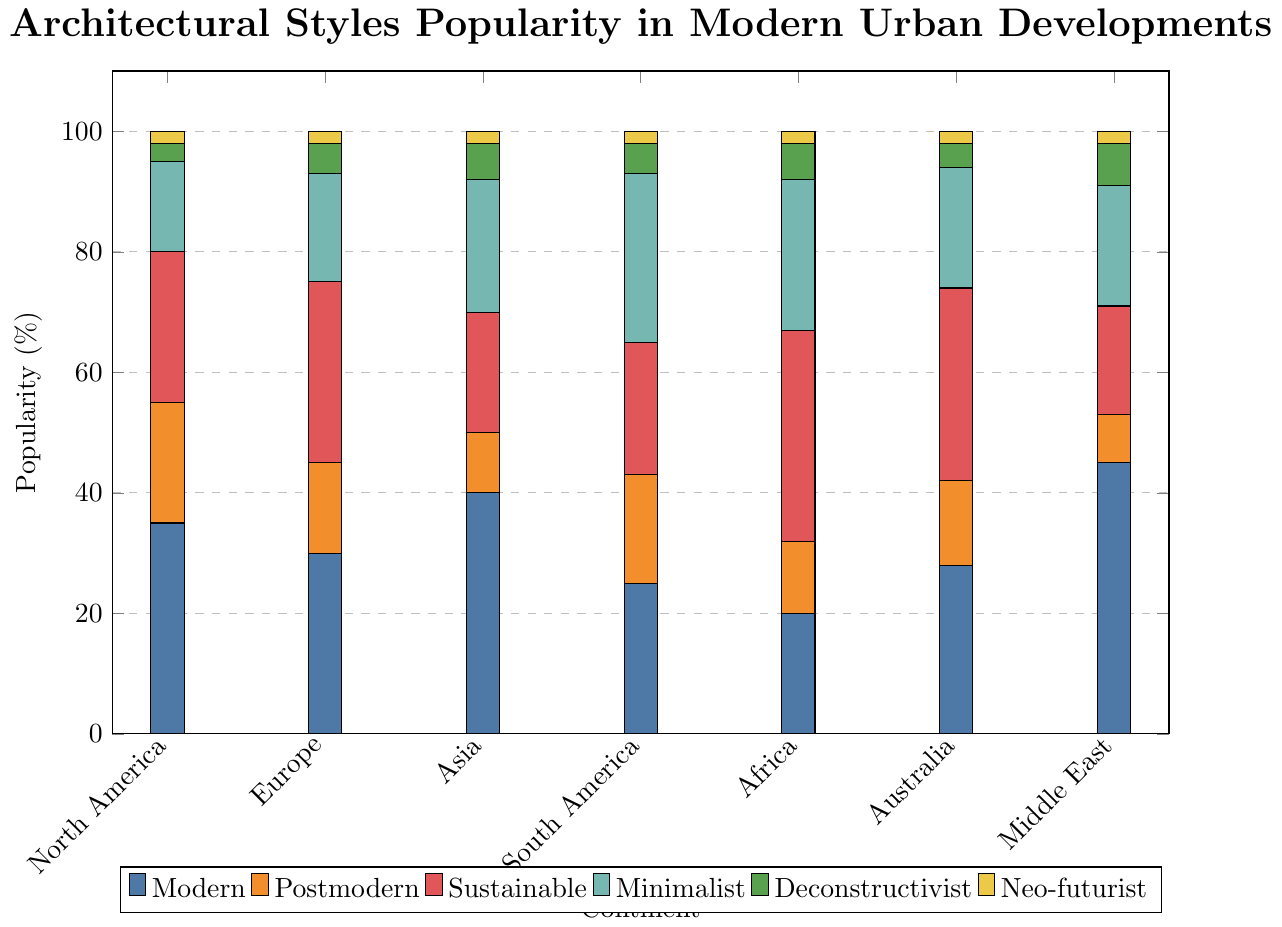Which continent has the highest popularity for Modern architecture? To find the highest popularity for Modern architecture, locate the tallest bar in the "Modern" category across all continents. The bar over the Middle East is the highest.
Answer: Middle East What is the total popularity percentage for Postmodern and Sustainable architecture in Europe? Look at the values for Postmodern (15) and Sustainable (30) architecture in Europe, then sum them up: 15 + 30 = 45
Answer: 45 Which continent exhibits the least popularity for Neo-futurist architecture? Identify the smallest bar segment representing Neo-futurist architecture across all continents. All continents have a Neo-futurist popularity of 2%.
Answer: All continents (each has 2%) Is Minimalist architecture more popular in Asia or Australia? Compare the bar heights for Minimalist architecture in Asia (22) and Australia (20). Asia has a higher value.
Answer: Asia By how much does Sustainable architecture in Africa exceed that in North America? Calculate the difference between Sustainable architecture values in Africa (35) and North America (25): 35 - 25 = 10
Answer: 10 What is the average popularity of Deconstructivist architecture across all continents? First, sum the Deconstructivist percentages across all continents: 3 + 5 + 6 + 5 + 6 + 4 + 7 = 36. Then, divide by the number of continents (7): 36 / 7 ≈ 5.14
Answer: 5.14 Which type of architecture has the highest combined popularity in South America? Sum the percentages for each type of architecture in South America: Modern (25), Postmodern (18), Sustainable (22), Minimalist (28), Deconstructivist (5), Neo-futurist (2). Minimalist has the highest sum.
Answer: Minimalist How does the popularity of Sustainable architecture in Europe compare to that in Australia? Compare the values for Sustainable architecture in Europe (30) and Australia (32). Sustainable is more popular in Australia.
Answer: Australia What is the overall trend in popularity for Modern architecture across continents? Analyze the bar heights for Modern architecture across continents: North America (35), Europe (30), Asia (40), South America (25), Africa (20), Australia (28), Middle East (45). The popularity varies with no clear upward or downward trend.
Answer: Varied Which continent has the lowest combined popularity percentage for the first four types of architecture (Modern, Postmodern, Sustainable, Minimalist)? Sum the first four columns' values for each continent and find the lowest sum: 
- North America: (35 + 20 + 25 + 15) = 95
- Europe: (30 + 15 + 30 + 18) = 93
- Asia: (40 + 10 + 20 + 22) = 92
- South America: (25 + 18 + 22 + 28) = 93
- Africa: (20 + 12 + 35 + 25) = 92
- Australia: (28 + 14 + 32 + 20) = 94
- Middle East: (45 + 8 + 18 + 20) = 91
The Middle East has the lowest combined popularity.
Answer: Middle East 